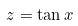<formula> <loc_0><loc_0><loc_500><loc_500>z = \tan x</formula> 